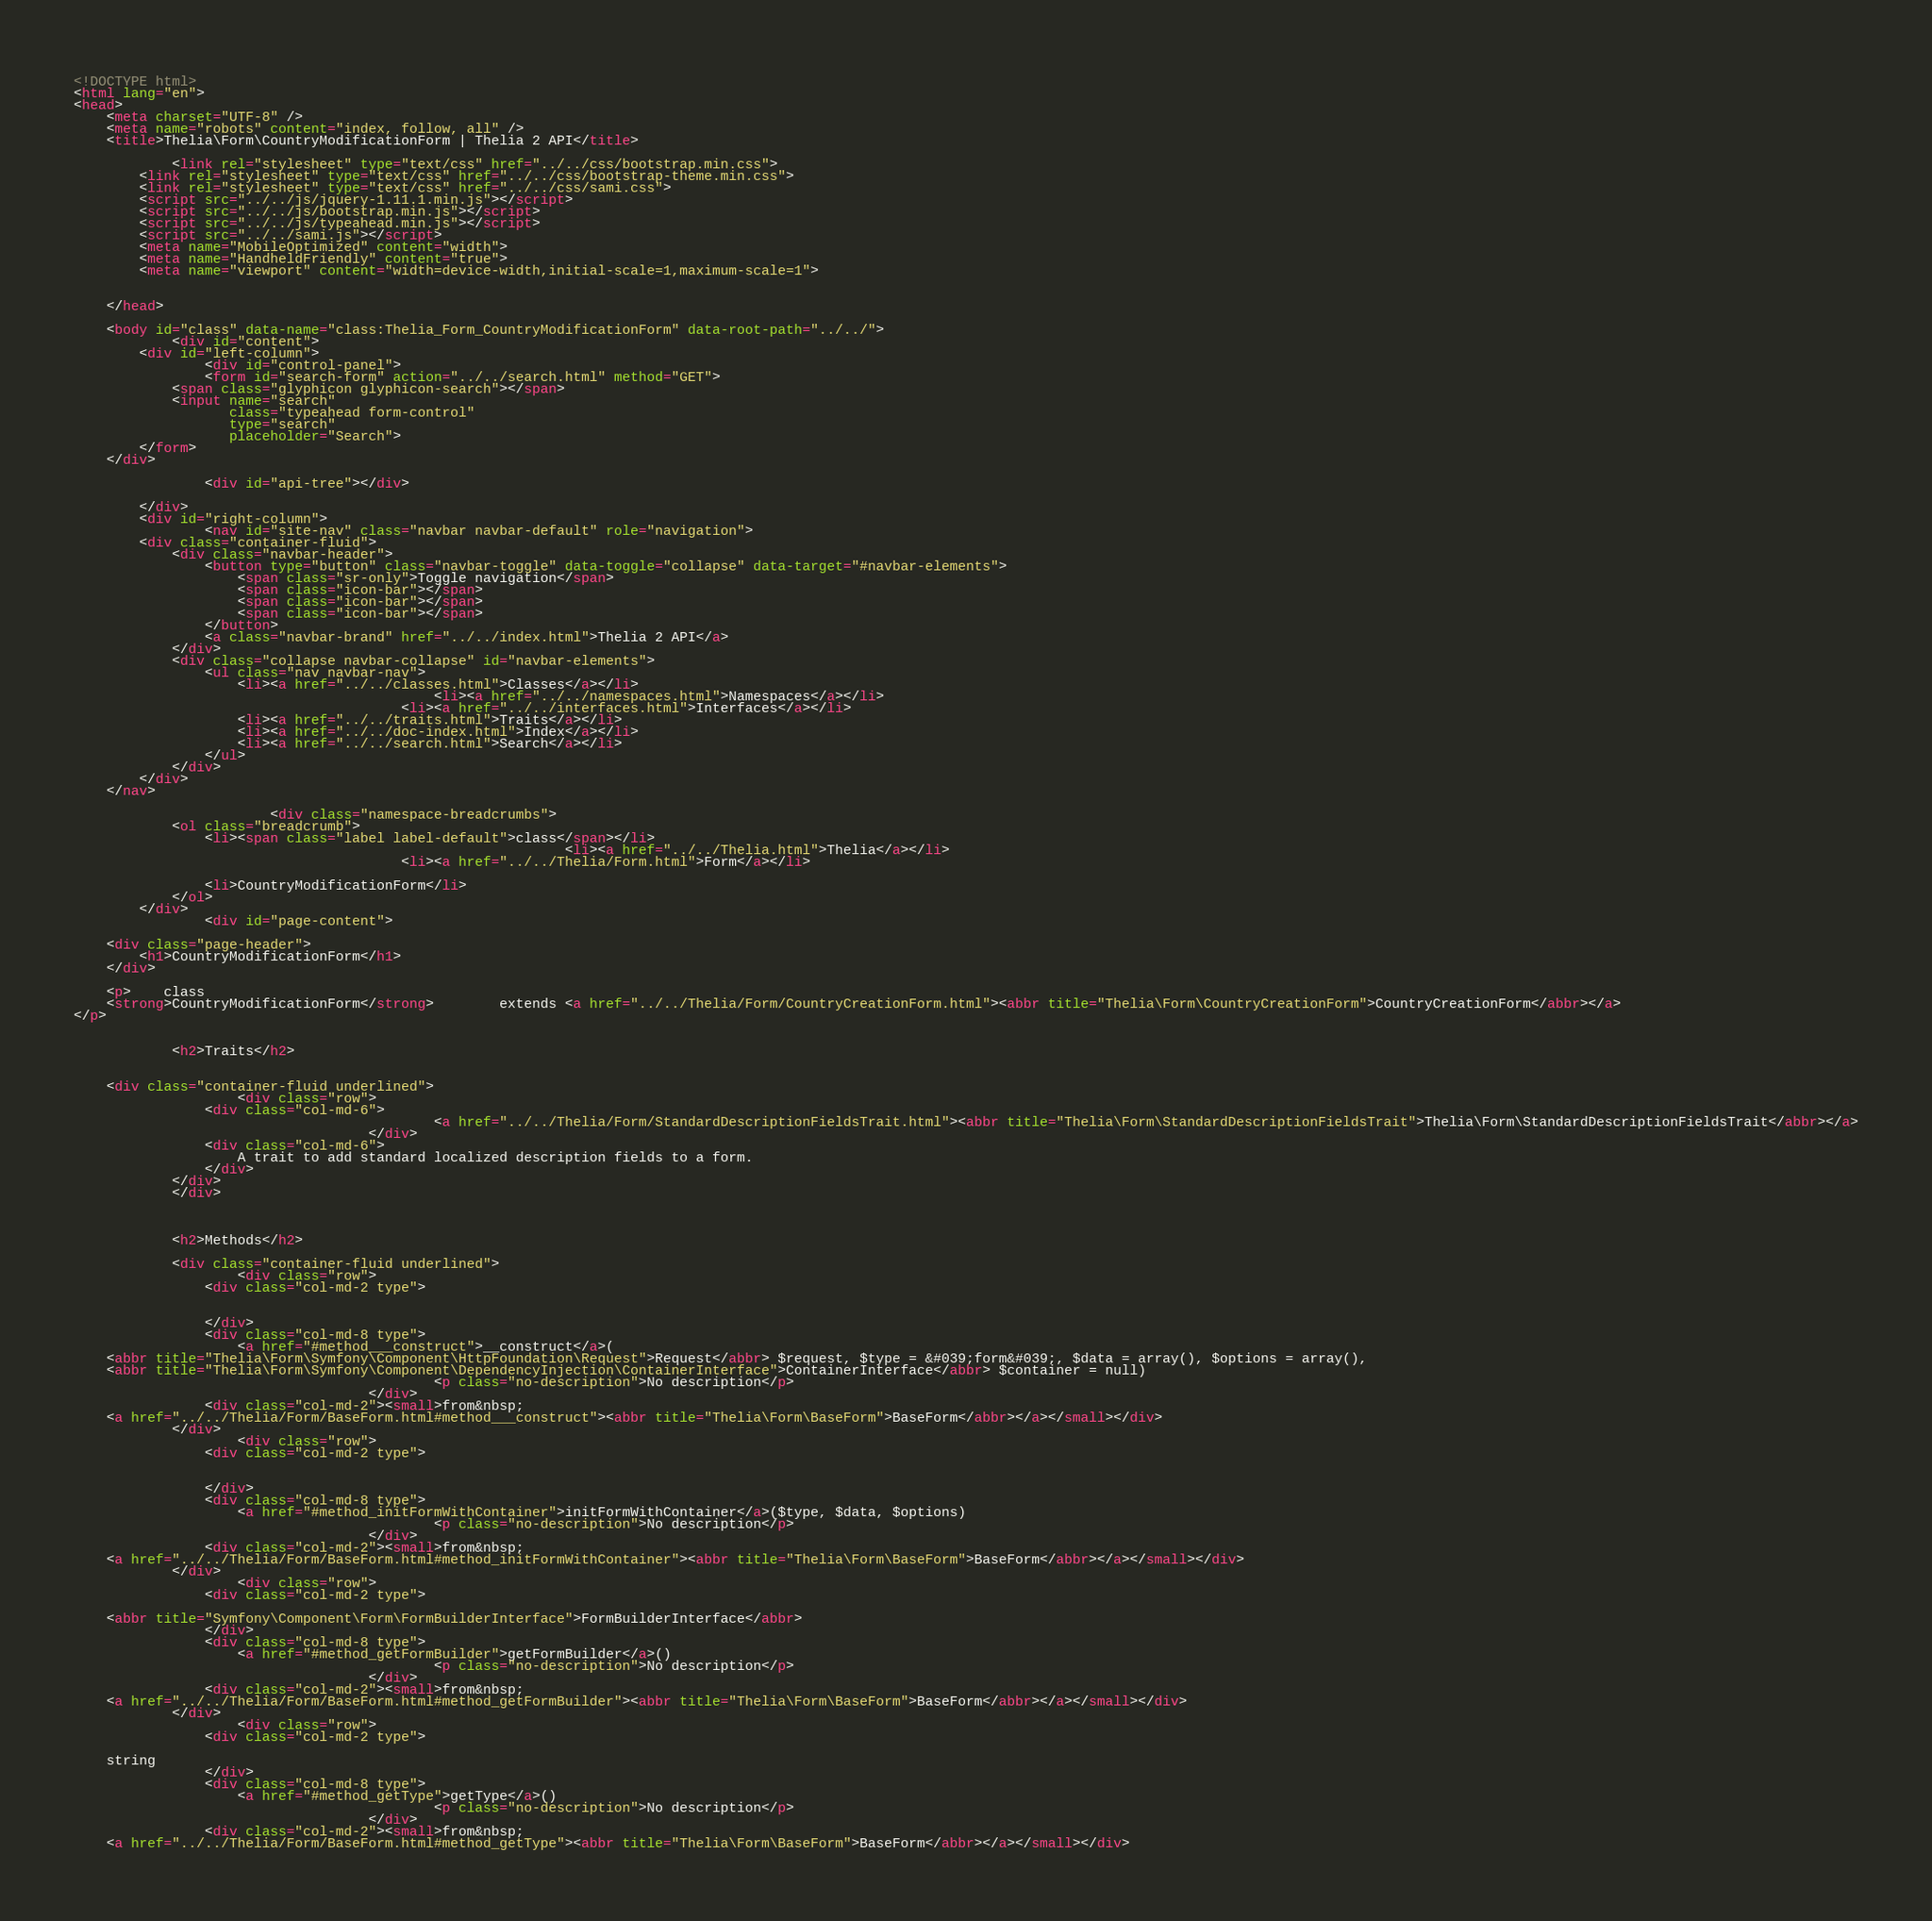<code> <loc_0><loc_0><loc_500><loc_500><_HTML_><!DOCTYPE html>
<html lang="en">
<head>
    <meta charset="UTF-8" />
    <meta name="robots" content="index, follow, all" />
    <title>Thelia\Form\CountryModificationForm | Thelia 2 API</title>

            <link rel="stylesheet" type="text/css" href="../../css/bootstrap.min.css">
        <link rel="stylesheet" type="text/css" href="../../css/bootstrap-theme.min.css">
        <link rel="stylesheet" type="text/css" href="../../css/sami.css">
        <script src="../../js/jquery-1.11.1.min.js"></script>
        <script src="../../js/bootstrap.min.js"></script>
        <script src="../../js/typeahead.min.js"></script>
        <script src="../../sami.js"></script>
        <meta name="MobileOptimized" content="width">
        <meta name="HandheldFriendly" content="true">
        <meta name="viewport" content="width=device-width,initial-scale=1,maximum-scale=1">
    
    
    </head>

    <body id="class" data-name="class:Thelia_Form_CountryModificationForm" data-root-path="../../">
            <div id="content">
        <div id="left-column">
                <div id="control-panel">
                <form id="search-form" action="../../search.html" method="GET">
            <span class="glyphicon glyphicon-search"></span>
            <input name="search"
                   class="typeahead form-control"
                   type="search"
                   placeholder="Search">
        </form>
    </div>

                <div id="api-tree"></div>

        </div>
        <div id="right-column">
                <nav id="site-nav" class="navbar navbar-default" role="navigation">
        <div class="container-fluid">
            <div class="navbar-header">
                <button type="button" class="navbar-toggle" data-toggle="collapse" data-target="#navbar-elements">
                    <span class="sr-only">Toggle navigation</span>
                    <span class="icon-bar"></span>
                    <span class="icon-bar"></span>
                    <span class="icon-bar"></span>
                </button>
                <a class="navbar-brand" href="../../index.html">Thelia 2 API</a>
            </div>
            <div class="collapse navbar-collapse" id="navbar-elements">
                <ul class="nav navbar-nav">
                    <li><a href="../../classes.html">Classes</a></li>
                                            <li><a href="../../namespaces.html">Namespaces</a></li>
                                        <li><a href="../../interfaces.html">Interfaces</a></li>
                    <li><a href="../../traits.html">Traits</a></li>
                    <li><a href="../../doc-index.html">Index</a></li>
                    <li><a href="../../search.html">Search</a></li>
                </ul>
            </div>
        </div>
    </nav>

                        <div class="namespace-breadcrumbs">
            <ol class="breadcrumb">
                <li><span class="label label-default">class</span></li>
                                                            <li><a href="../../Thelia.html">Thelia</a></li>
                                        <li><a href="../../Thelia/Form.html">Form</a></li>
    
                <li>CountryModificationForm</li>
            </ol>
        </div>
                <div id="page-content">
                
    <div class="page-header">
        <h1>CountryModificationForm</h1>
    </div>

    <p>    class
    <strong>CountryModificationForm</strong>        extends <a href="../../Thelia/Form/CountryCreationForm.html"><abbr title="Thelia\Form\CountryCreationForm">CountryCreationForm</abbr></a>
</p>

    
            <h2>Traits</h2>

        
    <div class="container-fluid underlined">
                    <div class="row">
                <div class="col-md-6">
                                            <a href="../../Thelia/Form/StandardDescriptionFieldsTrait.html"><abbr title="Thelia\Form\StandardDescriptionFieldsTrait">Thelia\Form\StandardDescriptionFieldsTrait</abbr></a>
                                    </div>
                <div class="col-md-6">
                    A trait to add standard localized description fields to a form.
                </div>
            </div>
            </div>
    
    
    
            <h2>Methods</h2>

            <div class="container-fluid underlined">
                    <div class="row">
                <div class="col-md-2 type">
                    
    
                </div>
                <div class="col-md-8 type">
                    <a href="#method___construct">__construct</a>(
    <abbr title="Thelia\Form\Symfony\Component\HttpFoundation\Request">Request</abbr> $request, $type = &#039;form&#039;, $data = array(), $options = array(), 
    <abbr title="Thelia\Form\Symfony\Component\DependencyInjection\ContainerInterface">ContainerInterface</abbr> $container = null)
                                            <p class="no-description">No description</p>
                                    </div>
                <div class="col-md-2"><small>from&nbsp;
    <a href="../../Thelia/Form/BaseForm.html#method___construct"><abbr title="Thelia\Form\BaseForm">BaseForm</abbr></a></small></div>
            </div>
                    <div class="row">
                <div class="col-md-2 type">
                    
    
                </div>
                <div class="col-md-8 type">
                    <a href="#method_initFormWithContainer">initFormWithContainer</a>($type, $data, $options)
                                            <p class="no-description">No description</p>
                                    </div>
                <div class="col-md-2"><small>from&nbsp;
    <a href="../../Thelia/Form/BaseForm.html#method_initFormWithContainer"><abbr title="Thelia\Form\BaseForm">BaseForm</abbr></a></small></div>
            </div>
                    <div class="row">
                <div class="col-md-2 type">
                    
    <abbr title="Symfony\Component\Form\FormBuilderInterface">FormBuilderInterface</abbr>
                </div>
                <div class="col-md-8 type">
                    <a href="#method_getFormBuilder">getFormBuilder</a>()
                                            <p class="no-description">No description</p>
                                    </div>
                <div class="col-md-2"><small>from&nbsp;
    <a href="../../Thelia/Form/BaseForm.html#method_getFormBuilder"><abbr title="Thelia\Form\BaseForm">BaseForm</abbr></a></small></div>
            </div>
                    <div class="row">
                <div class="col-md-2 type">
                    
    string
                </div>
                <div class="col-md-8 type">
                    <a href="#method_getType">getType</a>()
                                            <p class="no-description">No description</p>
                                    </div>
                <div class="col-md-2"><small>from&nbsp;
    <a href="../../Thelia/Form/BaseForm.html#method_getType"><abbr title="Thelia\Form\BaseForm">BaseForm</abbr></a></small></div></code> 